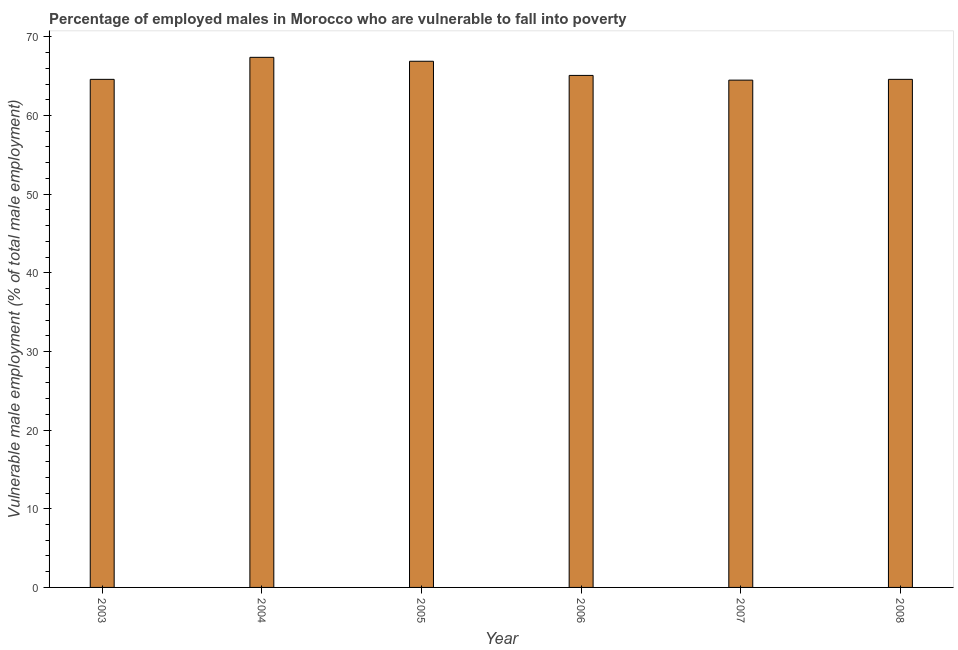Does the graph contain grids?
Provide a succinct answer. No. What is the title of the graph?
Offer a terse response. Percentage of employed males in Morocco who are vulnerable to fall into poverty. What is the label or title of the X-axis?
Your answer should be compact. Year. What is the label or title of the Y-axis?
Offer a terse response. Vulnerable male employment (% of total male employment). What is the percentage of employed males who are vulnerable to fall into poverty in 2003?
Your answer should be compact. 64.6. Across all years, what is the maximum percentage of employed males who are vulnerable to fall into poverty?
Your response must be concise. 67.4. Across all years, what is the minimum percentage of employed males who are vulnerable to fall into poverty?
Your response must be concise. 64.5. What is the sum of the percentage of employed males who are vulnerable to fall into poverty?
Offer a terse response. 393.1. What is the average percentage of employed males who are vulnerable to fall into poverty per year?
Your answer should be very brief. 65.52. What is the median percentage of employed males who are vulnerable to fall into poverty?
Keep it short and to the point. 64.85. What is the ratio of the percentage of employed males who are vulnerable to fall into poverty in 2003 to that in 2005?
Your answer should be compact. 0.97. What is the difference between the highest and the second highest percentage of employed males who are vulnerable to fall into poverty?
Provide a succinct answer. 0.5. Is the sum of the percentage of employed males who are vulnerable to fall into poverty in 2003 and 2005 greater than the maximum percentage of employed males who are vulnerable to fall into poverty across all years?
Offer a terse response. Yes. What is the difference between the highest and the lowest percentage of employed males who are vulnerable to fall into poverty?
Offer a very short reply. 2.9. What is the difference between two consecutive major ticks on the Y-axis?
Your response must be concise. 10. What is the Vulnerable male employment (% of total male employment) in 2003?
Provide a succinct answer. 64.6. What is the Vulnerable male employment (% of total male employment) in 2004?
Your response must be concise. 67.4. What is the Vulnerable male employment (% of total male employment) in 2005?
Ensure brevity in your answer.  66.9. What is the Vulnerable male employment (% of total male employment) in 2006?
Offer a terse response. 65.1. What is the Vulnerable male employment (% of total male employment) of 2007?
Offer a terse response. 64.5. What is the Vulnerable male employment (% of total male employment) of 2008?
Your answer should be compact. 64.6. What is the difference between the Vulnerable male employment (% of total male employment) in 2003 and 2005?
Your answer should be very brief. -2.3. What is the difference between the Vulnerable male employment (% of total male employment) in 2003 and 2006?
Provide a succinct answer. -0.5. What is the difference between the Vulnerable male employment (% of total male employment) in 2003 and 2008?
Offer a very short reply. 0. What is the difference between the Vulnerable male employment (% of total male employment) in 2004 and 2005?
Your answer should be compact. 0.5. What is the difference between the Vulnerable male employment (% of total male employment) in 2004 and 2006?
Offer a terse response. 2.3. What is the difference between the Vulnerable male employment (% of total male employment) in 2004 and 2008?
Your answer should be compact. 2.8. What is the difference between the Vulnerable male employment (% of total male employment) in 2005 and 2007?
Your answer should be compact. 2.4. What is the difference between the Vulnerable male employment (% of total male employment) in 2006 and 2007?
Your answer should be compact. 0.6. What is the ratio of the Vulnerable male employment (% of total male employment) in 2003 to that in 2004?
Your answer should be very brief. 0.96. What is the ratio of the Vulnerable male employment (% of total male employment) in 2003 to that in 2005?
Make the answer very short. 0.97. What is the ratio of the Vulnerable male employment (% of total male employment) in 2003 to that in 2006?
Provide a succinct answer. 0.99. What is the ratio of the Vulnerable male employment (% of total male employment) in 2003 to that in 2008?
Provide a succinct answer. 1. What is the ratio of the Vulnerable male employment (% of total male employment) in 2004 to that in 2006?
Provide a short and direct response. 1.03. What is the ratio of the Vulnerable male employment (% of total male employment) in 2004 to that in 2007?
Your response must be concise. 1.04. What is the ratio of the Vulnerable male employment (% of total male employment) in 2004 to that in 2008?
Provide a succinct answer. 1.04. What is the ratio of the Vulnerable male employment (% of total male employment) in 2005 to that in 2006?
Your answer should be compact. 1.03. What is the ratio of the Vulnerable male employment (% of total male employment) in 2005 to that in 2008?
Your answer should be very brief. 1.04. 